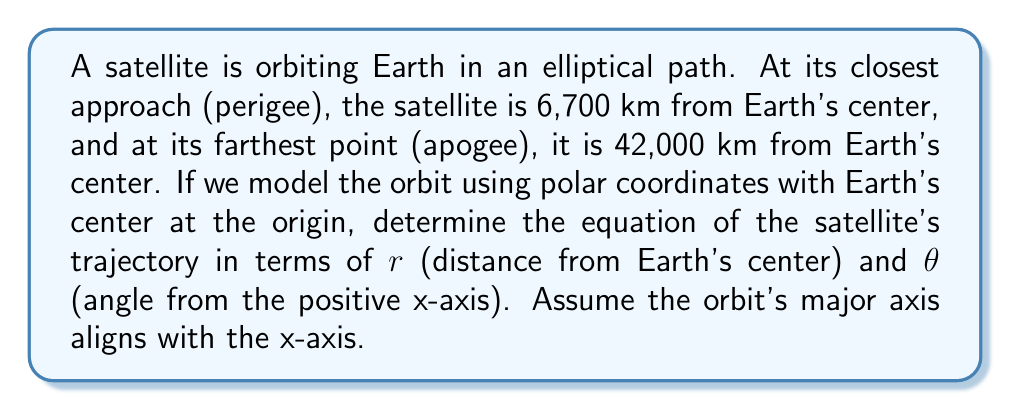Can you solve this math problem? Let's approach this step-by-step:

1) The general equation for an ellipse in polar coordinates is:

   $$r = \frac{ep}{1 - e\cos\theta}$$

   where $e$ is the eccentricity and $p$ is the parameter of the ellipse.

2) We need to find $e$ and $p$. Let's start with $e$:
   
   The eccentricity is given by $e = \frac{r_a - r_p}{r_a + r_p}$, where $r_a$ is the apogee distance and $r_p$ is the perigee distance.

   $$e = \frac{42000 - 6700}{42000 + 6700} = \frac{35300}{48700} \approx 0.7248$$

3) Now, let's find $p$. We can use either the apogee or perigee distance:

   At perigee, $\theta = 0$, so:
   $$r_p = \frac{ep}{1 - e} \implies p = \frac{r_p(1-e)}{e}$$

   $$p = \frac{6700(1-0.7248)}{0.7248} \approx 2542.5 \text{ km}$$

4) Now we have both $e$ and $p$, we can write the equation of the orbit:

   $$r = \frac{1843.125}{1 - 0.7248\cos\theta}$$

5) To verify, let's check the apogee distance ($\theta = \pi$):

   $$r = \frac{1843.125}{1 - 0.7248\cos\pi} = \frac{1843.125}{1 + 0.7248} \approx 42000 \text{ km}$$

   This matches our given apogee distance.
Answer: $$r = \frac{1843.125}{1 - 0.7248\cos\theta}$$ 